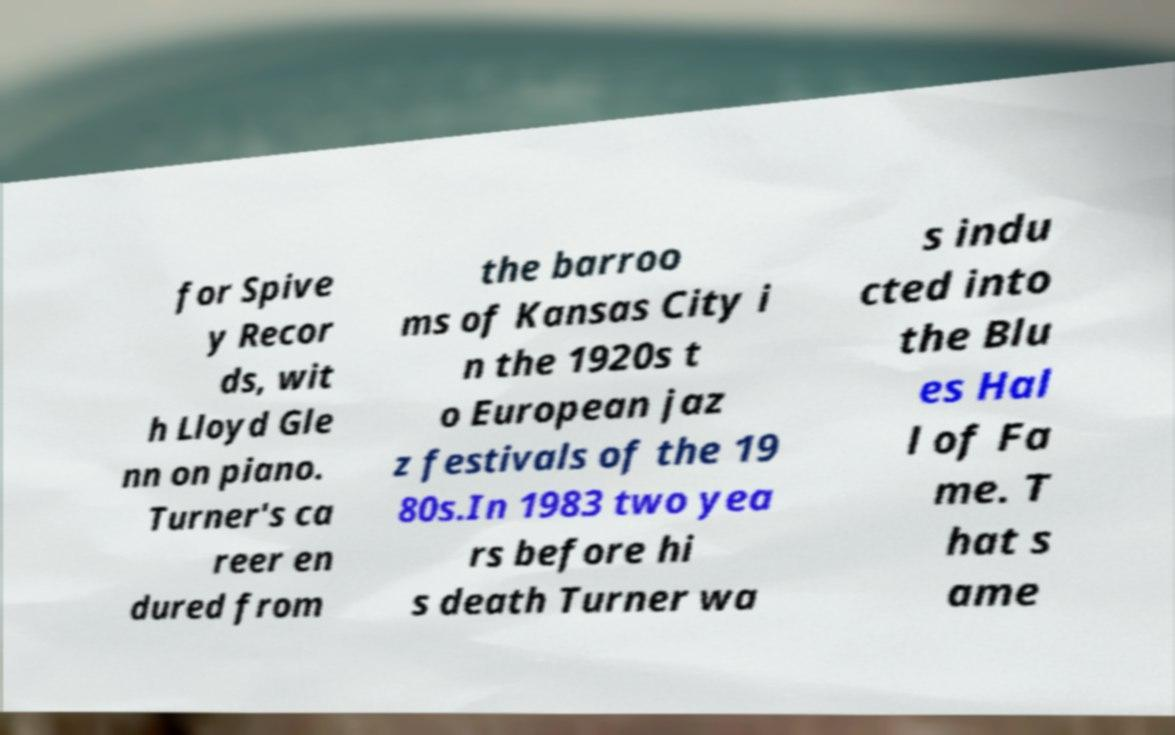What messages or text are displayed in this image? I need them in a readable, typed format. for Spive y Recor ds, wit h Lloyd Gle nn on piano. Turner's ca reer en dured from the barroo ms of Kansas City i n the 1920s t o European jaz z festivals of the 19 80s.In 1983 two yea rs before hi s death Turner wa s indu cted into the Blu es Hal l of Fa me. T hat s ame 